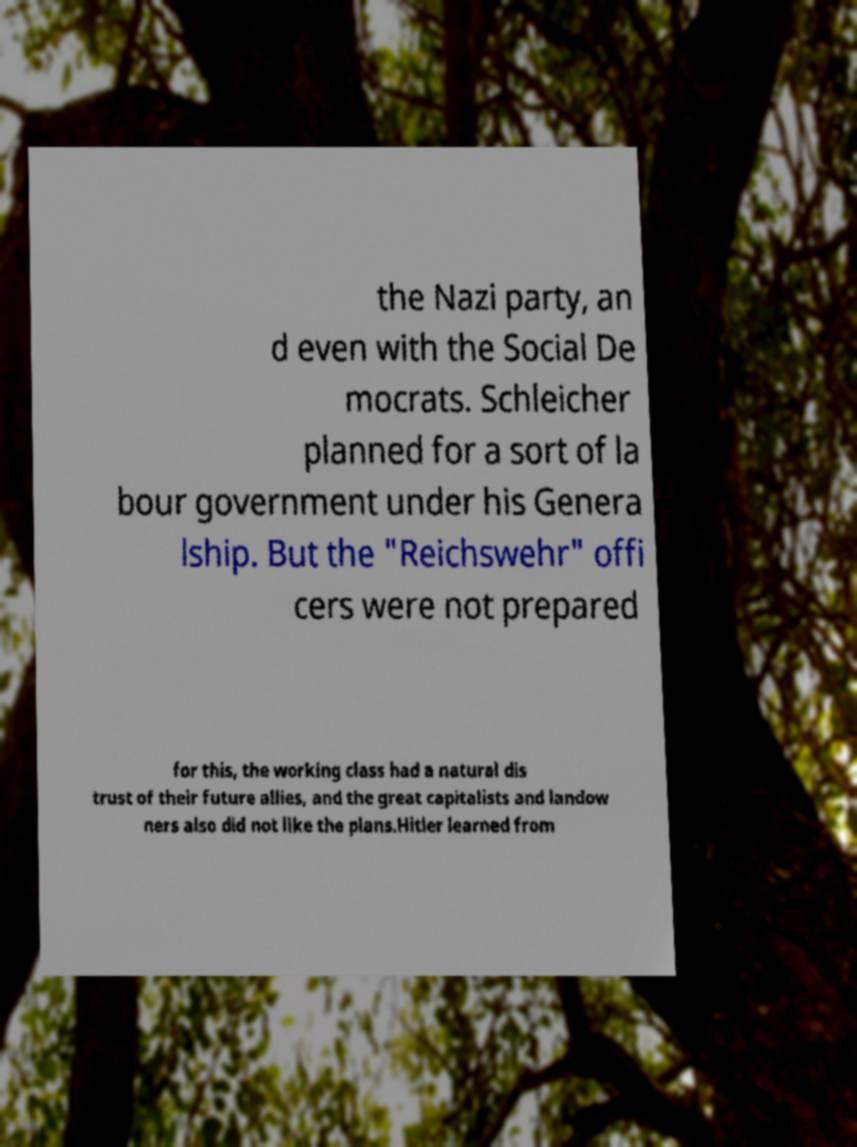What messages or text are displayed in this image? I need them in a readable, typed format. the Nazi party, an d even with the Social De mocrats. Schleicher planned for a sort of la bour government under his Genera lship. But the "Reichswehr" offi cers were not prepared for this, the working class had a natural dis trust of their future allies, and the great capitalists and landow ners also did not like the plans.Hitler learned from 